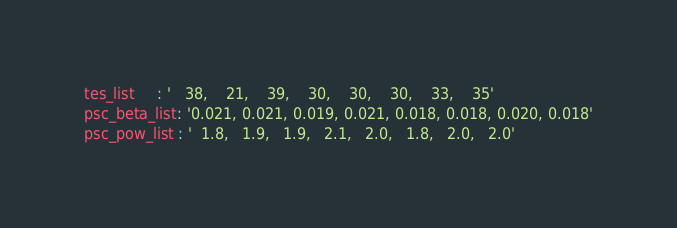<code> <loc_0><loc_0><loc_500><loc_500><_YAML_>tes_list     : '   38,    21,    39,    30,    30,    30,    33,    35'
psc_beta_list: '0.021, 0.021, 0.019, 0.021, 0.018, 0.018, 0.020, 0.018'
psc_pow_list : '  1.8,   1.9,   1.9,   2.1,   2.0,   1.8,   2.0,   2.0'
</code> 